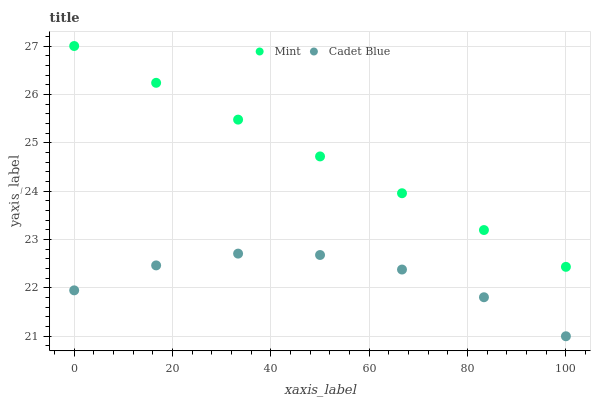Does Cadet Blue have the minimum area under the curve?
Answer yes or no. Yes. Does Mint have the maximum area under the curve?
Answer yes or no. Yes. Does Mint have the minimum area under the curve?
Answer yes or no. No. Is Mint the smoothest?
Answer yes or no. Yes. Is Cadet Blue the roughest?
Answer yes or no. Yes. Is Mint the roughest?
Answer yes or no. No. Does Cadet Blue have the lowest value?
Answer yes or no. Yes. Does Mint have the lowest value?
Answer yes or no. No. Does Mint have the highest value?
Answer yes or no. Yes. Is Cadet Blue less than Mint?
Answer yes or no. Yes. Is Mint greater than Cadet Blue?
Answer yes or no. Yes. Does Cadet Blue intersect Mint?
Answer yes or no. No. 